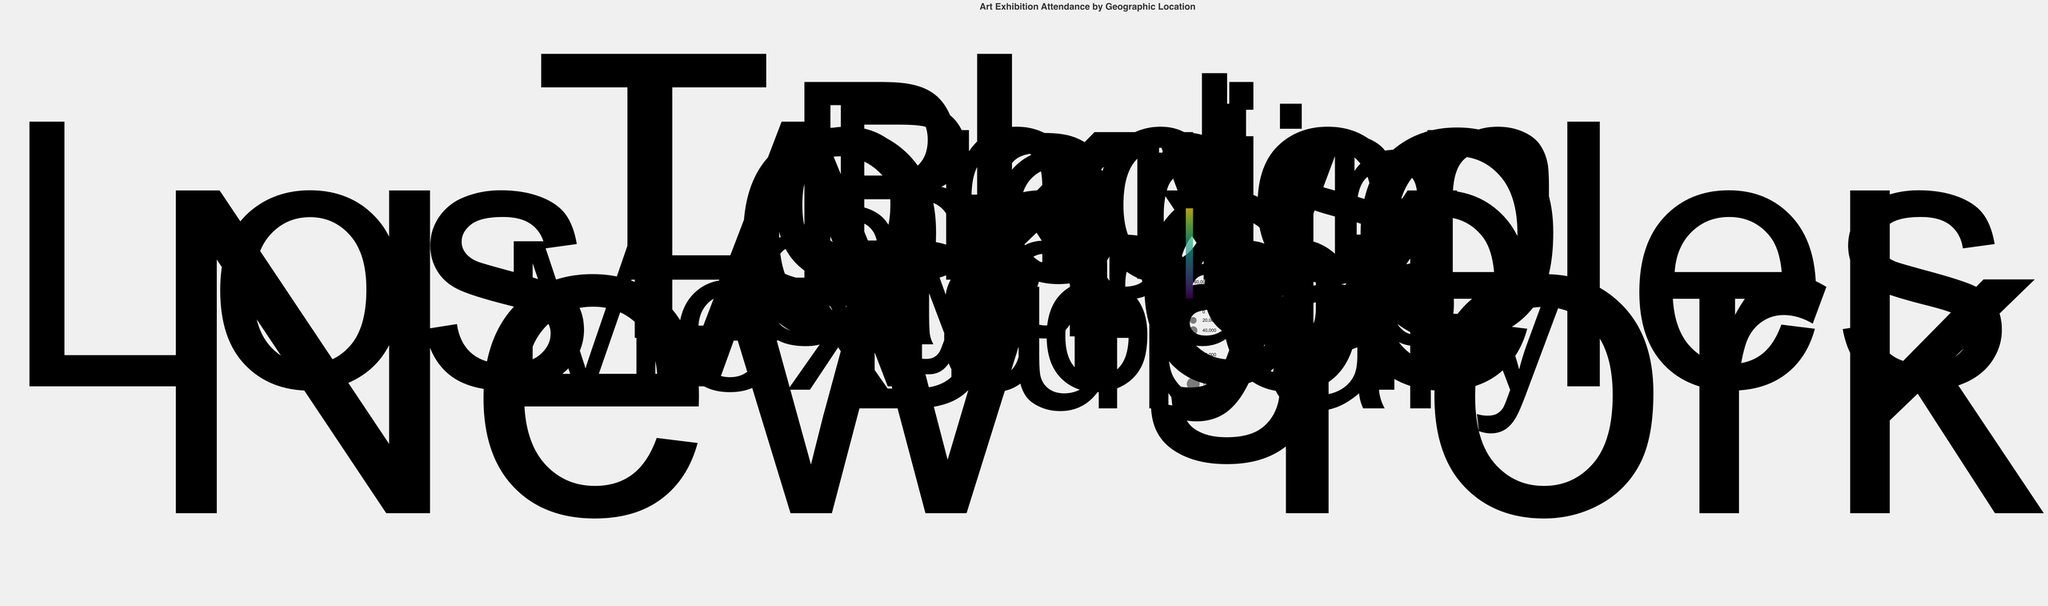what is the title of the figure? The title is located at the top of the chart, stating the main subject which the data represents.
Answer: Art Exhibition Attendance by Geographic Location How many cities are represented in the figure? Count the number of unique data points (locations) plotted on the Polar Scatter Chart.
Answer: 10 Which city has the lowest attendance? Look for the smallest circle on the chart and check the tooltip or label for the corresponding city and its attendance.
Answer: São Paulo What is the color scheme used and what does it represent? The color scheme, displayed in varying intensities, maps to the attendance numbers. It follows the viridis color scale ranging from lighter to darker shades.
Answer: The viridis color scheme represents attendance Which city has a larger attendance, Paris or Mexico City? Compare the size and color intensity of the plotted points associated with Paris and Mexico City.
Answer: Paris Can you list the top three cities in terms of art exhibition attendance? Identify the three largest and most intense-colored points on the chart, using tooltips or labels for reference.
Answer: New York, Tokyo, Los Angeles How do the locations closest to the polar center compare in attendance? Examine the sizes and colors of dots near the polar chart's center; these represent locations with smaller latitudes and longitudes.
Answer: Sydney and São Paulo have lower attendance compared to other cities Which geographic location has a higher latitude, Tokyo or London? Match the radius values to find the points corresponding to Tokyo and London, and compare their distances from the center.
Answer: London What is the attendance difference between New York and Los Angeles? Check the attendance values for New York and Los Angeles and calculate the difference.
Answer: 30,000 How does Tokyo's attendance compare to that of Berlin? Compare the attendance values indicated by the point sizes and colors of Tokyo and Berlin.
Answer: Tokyo has higher attendance 